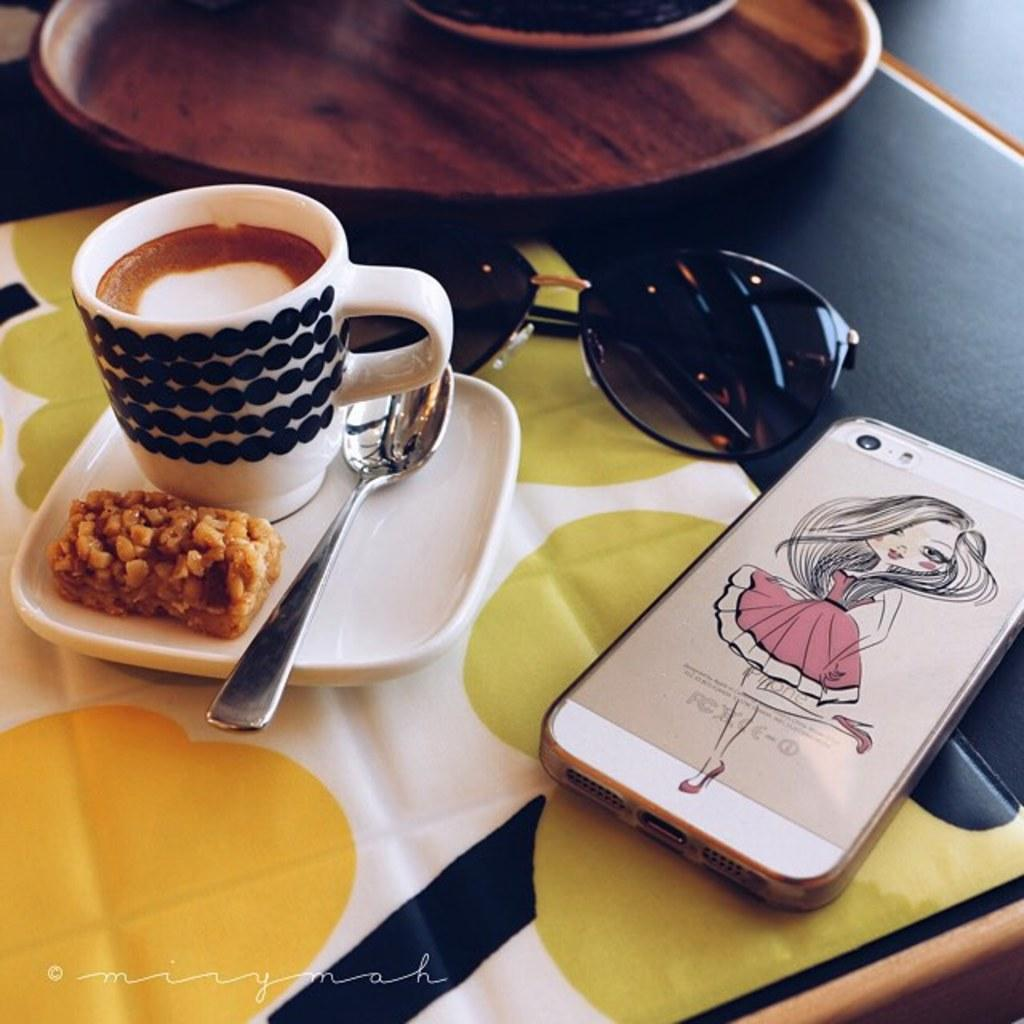What object can be seen hanging in the image? There is a mobile in the image. What accessory is visible in the image? There are sunglasses in the image. What type of container is present in the image? There is a cup in the image. What is used to hold the cup in the image? There is a saucer in the image. What utensil is present in the image? There is a spoon in the image. What type of establishment is depicted in the image? There is a bar in the image. What items might be used for cleaning or wiping in the image? There are napkins in the image. What is used to serve food in the image? There is a plate in the image. What type of silk is draped over the bar in the image? There is no silk present in the image. What joke is being told by the mobile in the image? The mobile is an inanimate object and cannot tell jokes. 